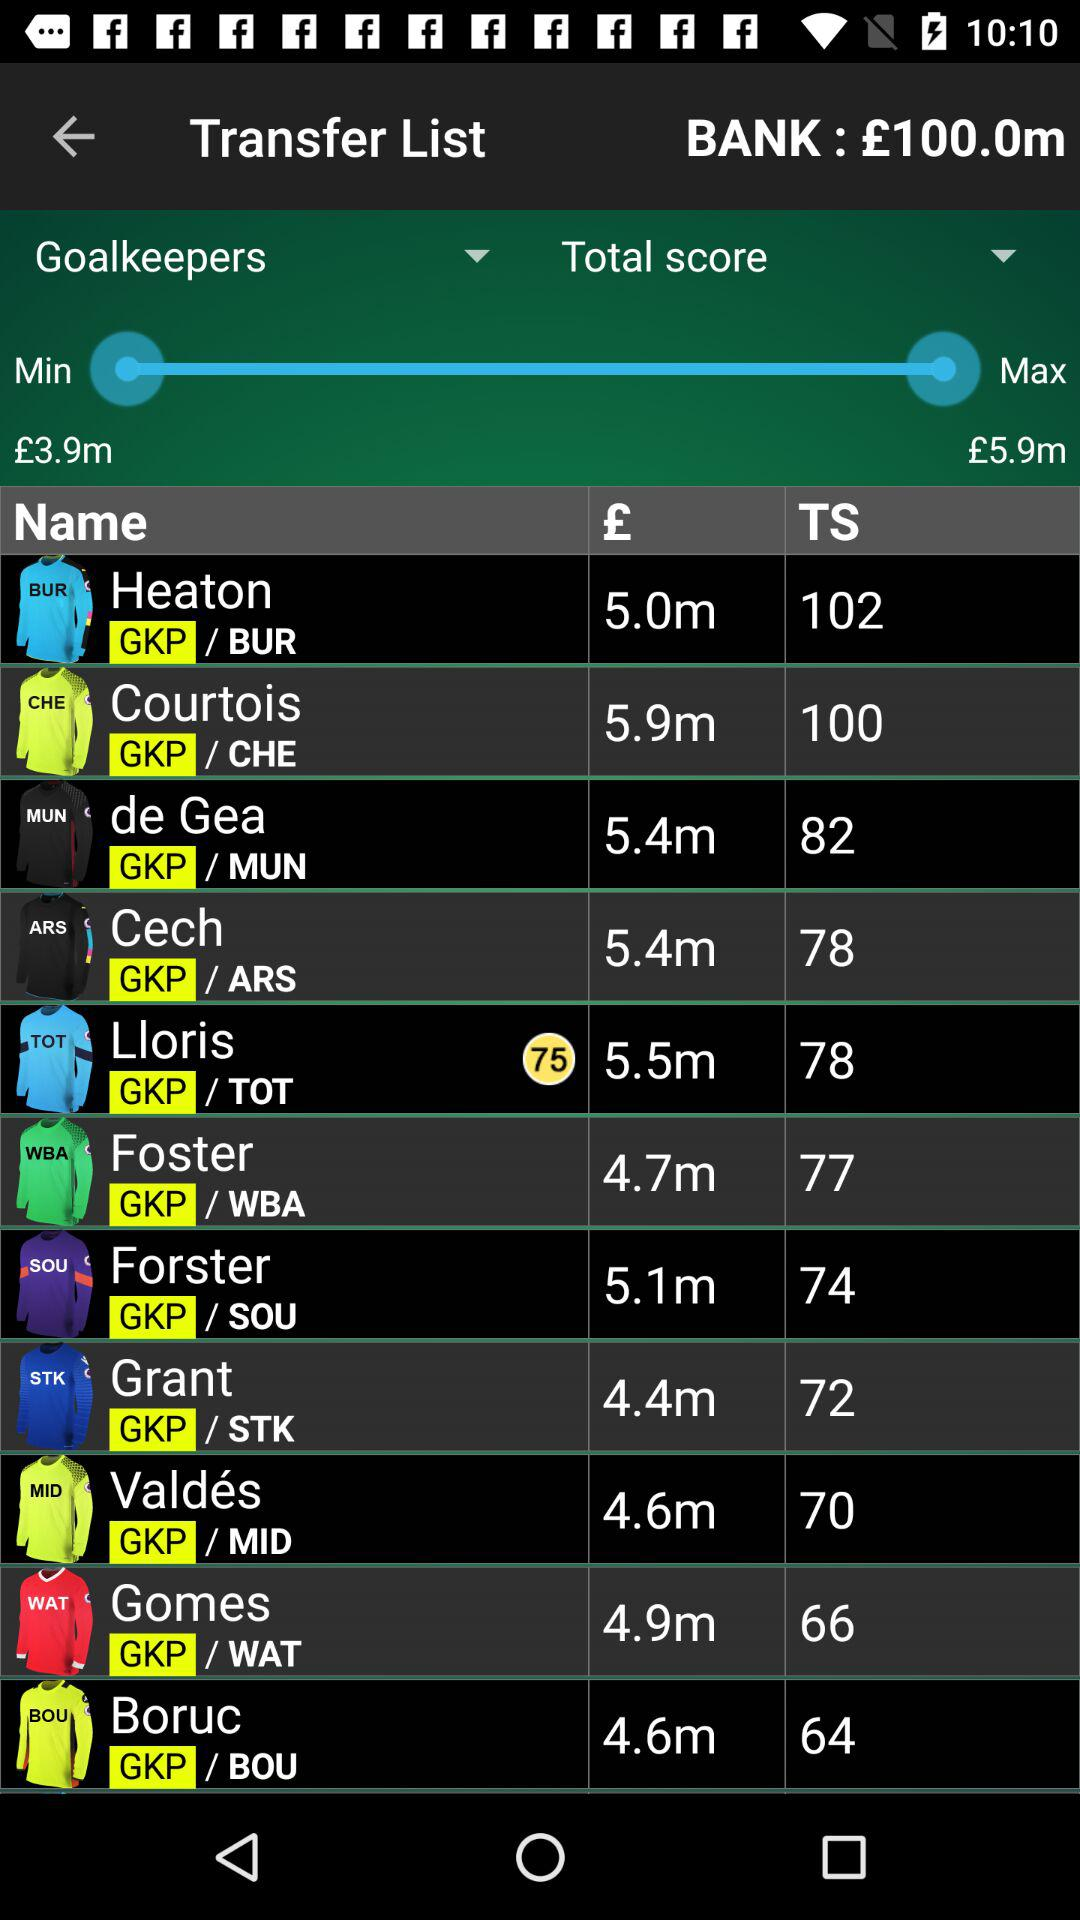Which goalkeeper has the lowest price?
Answer the question using a single word or phrase. Grant 